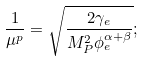<formula> <loc_0><loc_0><loc_500><loc_500>\frac { 1 } { \mu ^ { p } } = \sqrt { \frac { 2 \gamma _ { e } } { M _ { P } ^ { 2 } \phi _ { e } ^ { \alpha + \beta } } } ;</formula> 